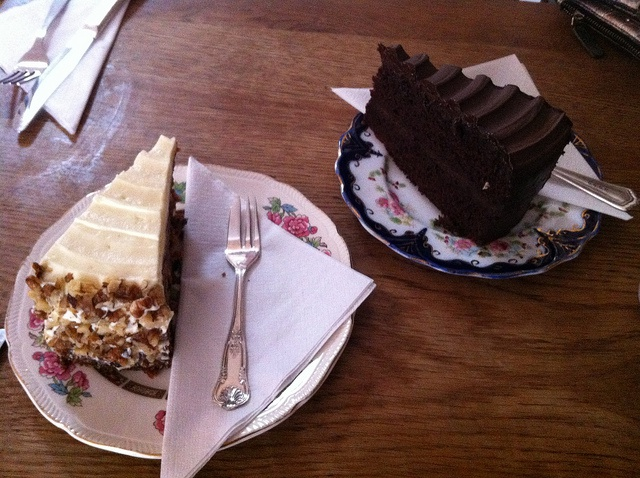Describe the objects in this image and their specific colors. I can see dining table in maroon, black, brown, and darkgray tones, cake in maroon, black, and gray tones, cake in maroon, lightgray, tan, and black tones, fork in maroon, darkgray, gray, lightpink, and lavender tones, and knife in maroon, white, gray, and darkgray tones in this image. 